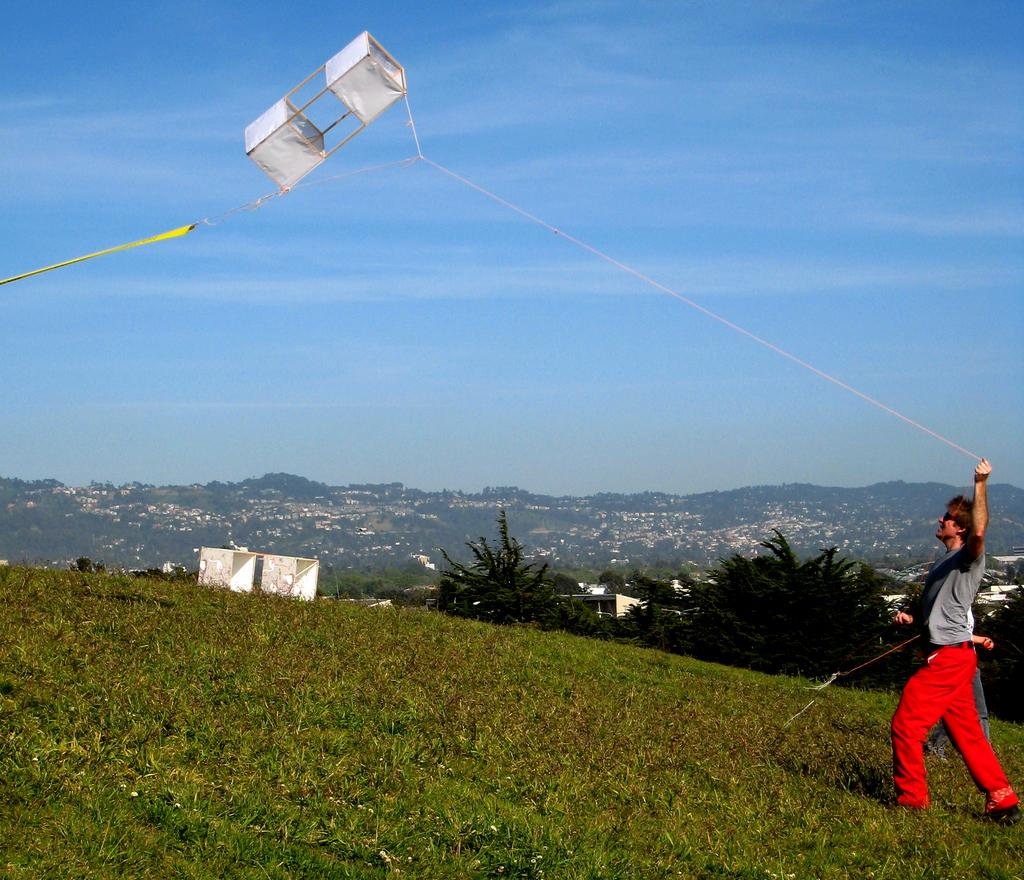How many people are walking in the image? There are two persons walking in the image. What is one of the persons holding in their hand? One person is holding a thread in their hand. What can be seen in the background of the image? There are trees, hills, and the sky visible in the background of the image. What is the condition of the sky in the image? Clouds are present in the sky. What type of ornament is hanging from the trees in the image? There is no ornament hanging from the trees in the image; only trees, hills, and the sky are visible in the background. Can you tell me what the argument is about between the two persons in the image? There is no argument depicted in the image; it shows two persons walking and one holding a thread. 